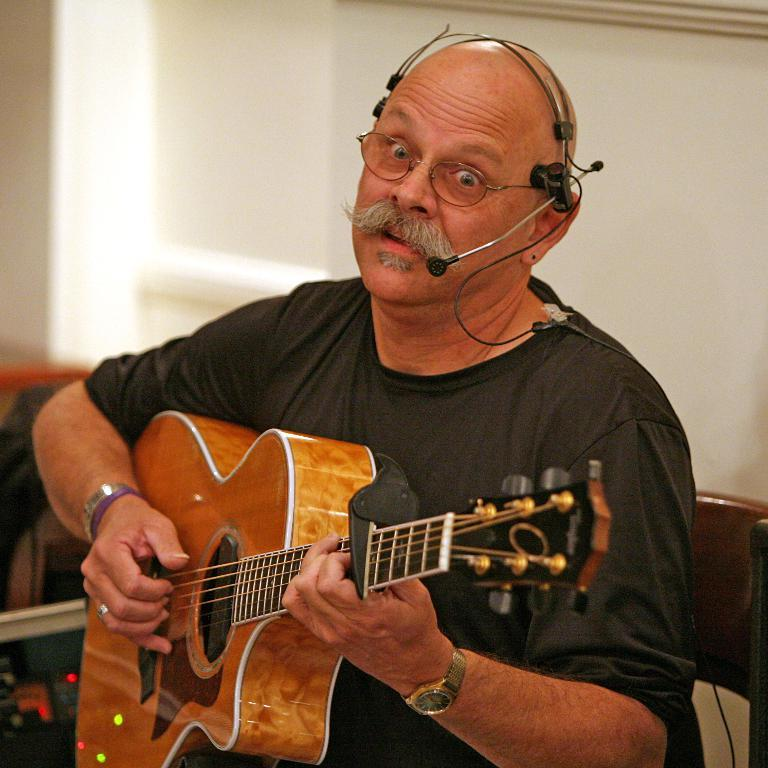What is the man in the image doing? The man is playing a guitar in the image. What can be seen in the background of the image? There is a wall in the background of the image. How many boys are playing castanets in the image? There are no boys or castanets present in the image; it features a man playing a guitar. 